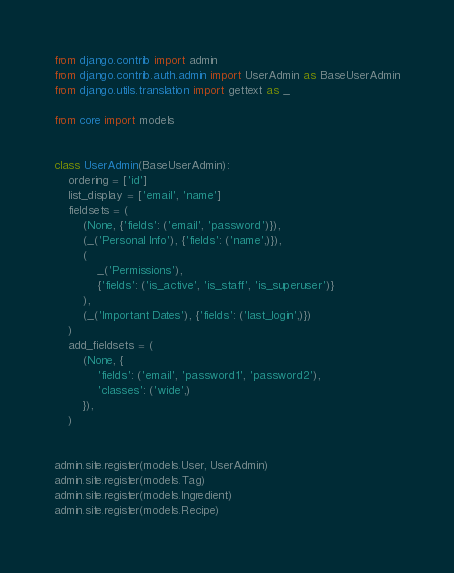Convert code to text. <code><loc_0><loc_0><loc_500><loc_500><_Python_>from django.contrib import admin
from django.contrib.auth.admin import UserAdmin as BaseUserAdmin
from django.utils.translation import gettext as _

from core import models


class UserAdmin(BaseUserAdmin):
    ordering = ['id']
    list_display = ['email', 'name']
    fieldsets = (
        (None, {'fields': ('email', 'password')}),
        (_('Personal Info'), {'fields': ('name',)}),
        (
            _('Permissions'),
            {'fields': ('is_active', 'is_staff', 'is_superuser')}
        ),
        (_('Important Dates'), {'fields': ('last_login',)})
    )
    add_fieldsets = (
        (None, {
            'fields': ('email', 'password1', 'password2'),
            'classes': ('wide',)
        }),
    )


admin.site.register(models.User, UserAdmin)
admin.site.register(models.Tag)
admin.site.register(models.Ingredient)
admin.site.register(models.Recipe)
</code> 